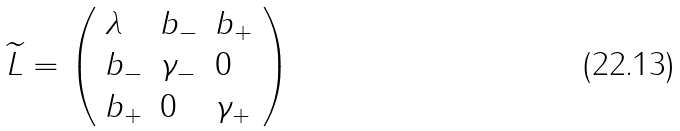<formula> <loc_0><loc_0><loc_500><loc_500>\widetilde { L } = \left ( \begin{array} { l l l } \lambda & b _ { - } & b _ { + } \\ b _ { - } & \gamma _ { - } & 0 \\ b _ { + } & 0 & \gamma _ { + } \end{array} \right )</formula> 